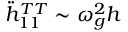Convert formula to latex. <formula><loc_0><loc_0><loc_500><loc_500>\ddot { h } _ { 1 1 } ^ { T T } \sim \omega _ { g } ^ { 2 } h</formula> 